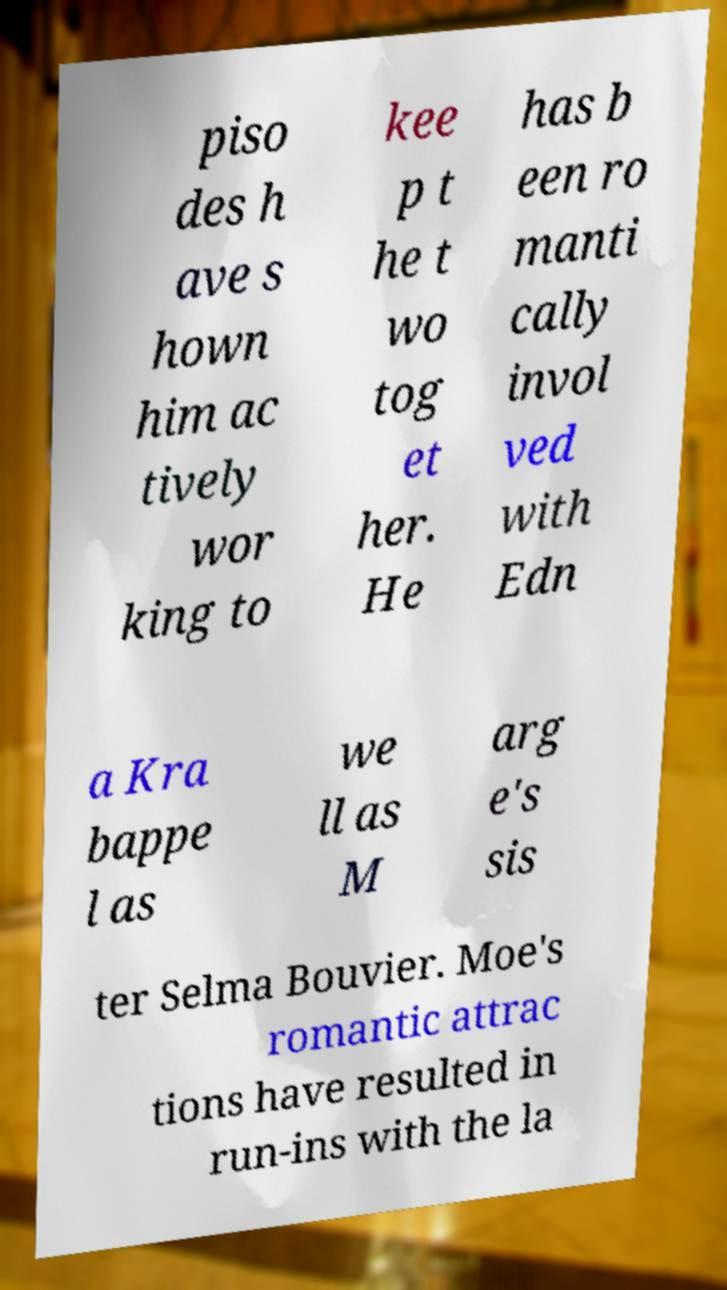Please read and relay the text visible in this image. What does it say? piso des h ave s hown him ac tively wor king to kee p t he t wo tog et her. He has b een ro manti cally invol ved with Edn a Kra bappe l as we ll as M arg e's sis ter Selma Bouvier. Moe's romantic attrac tions have resulted in run-ins with the la 